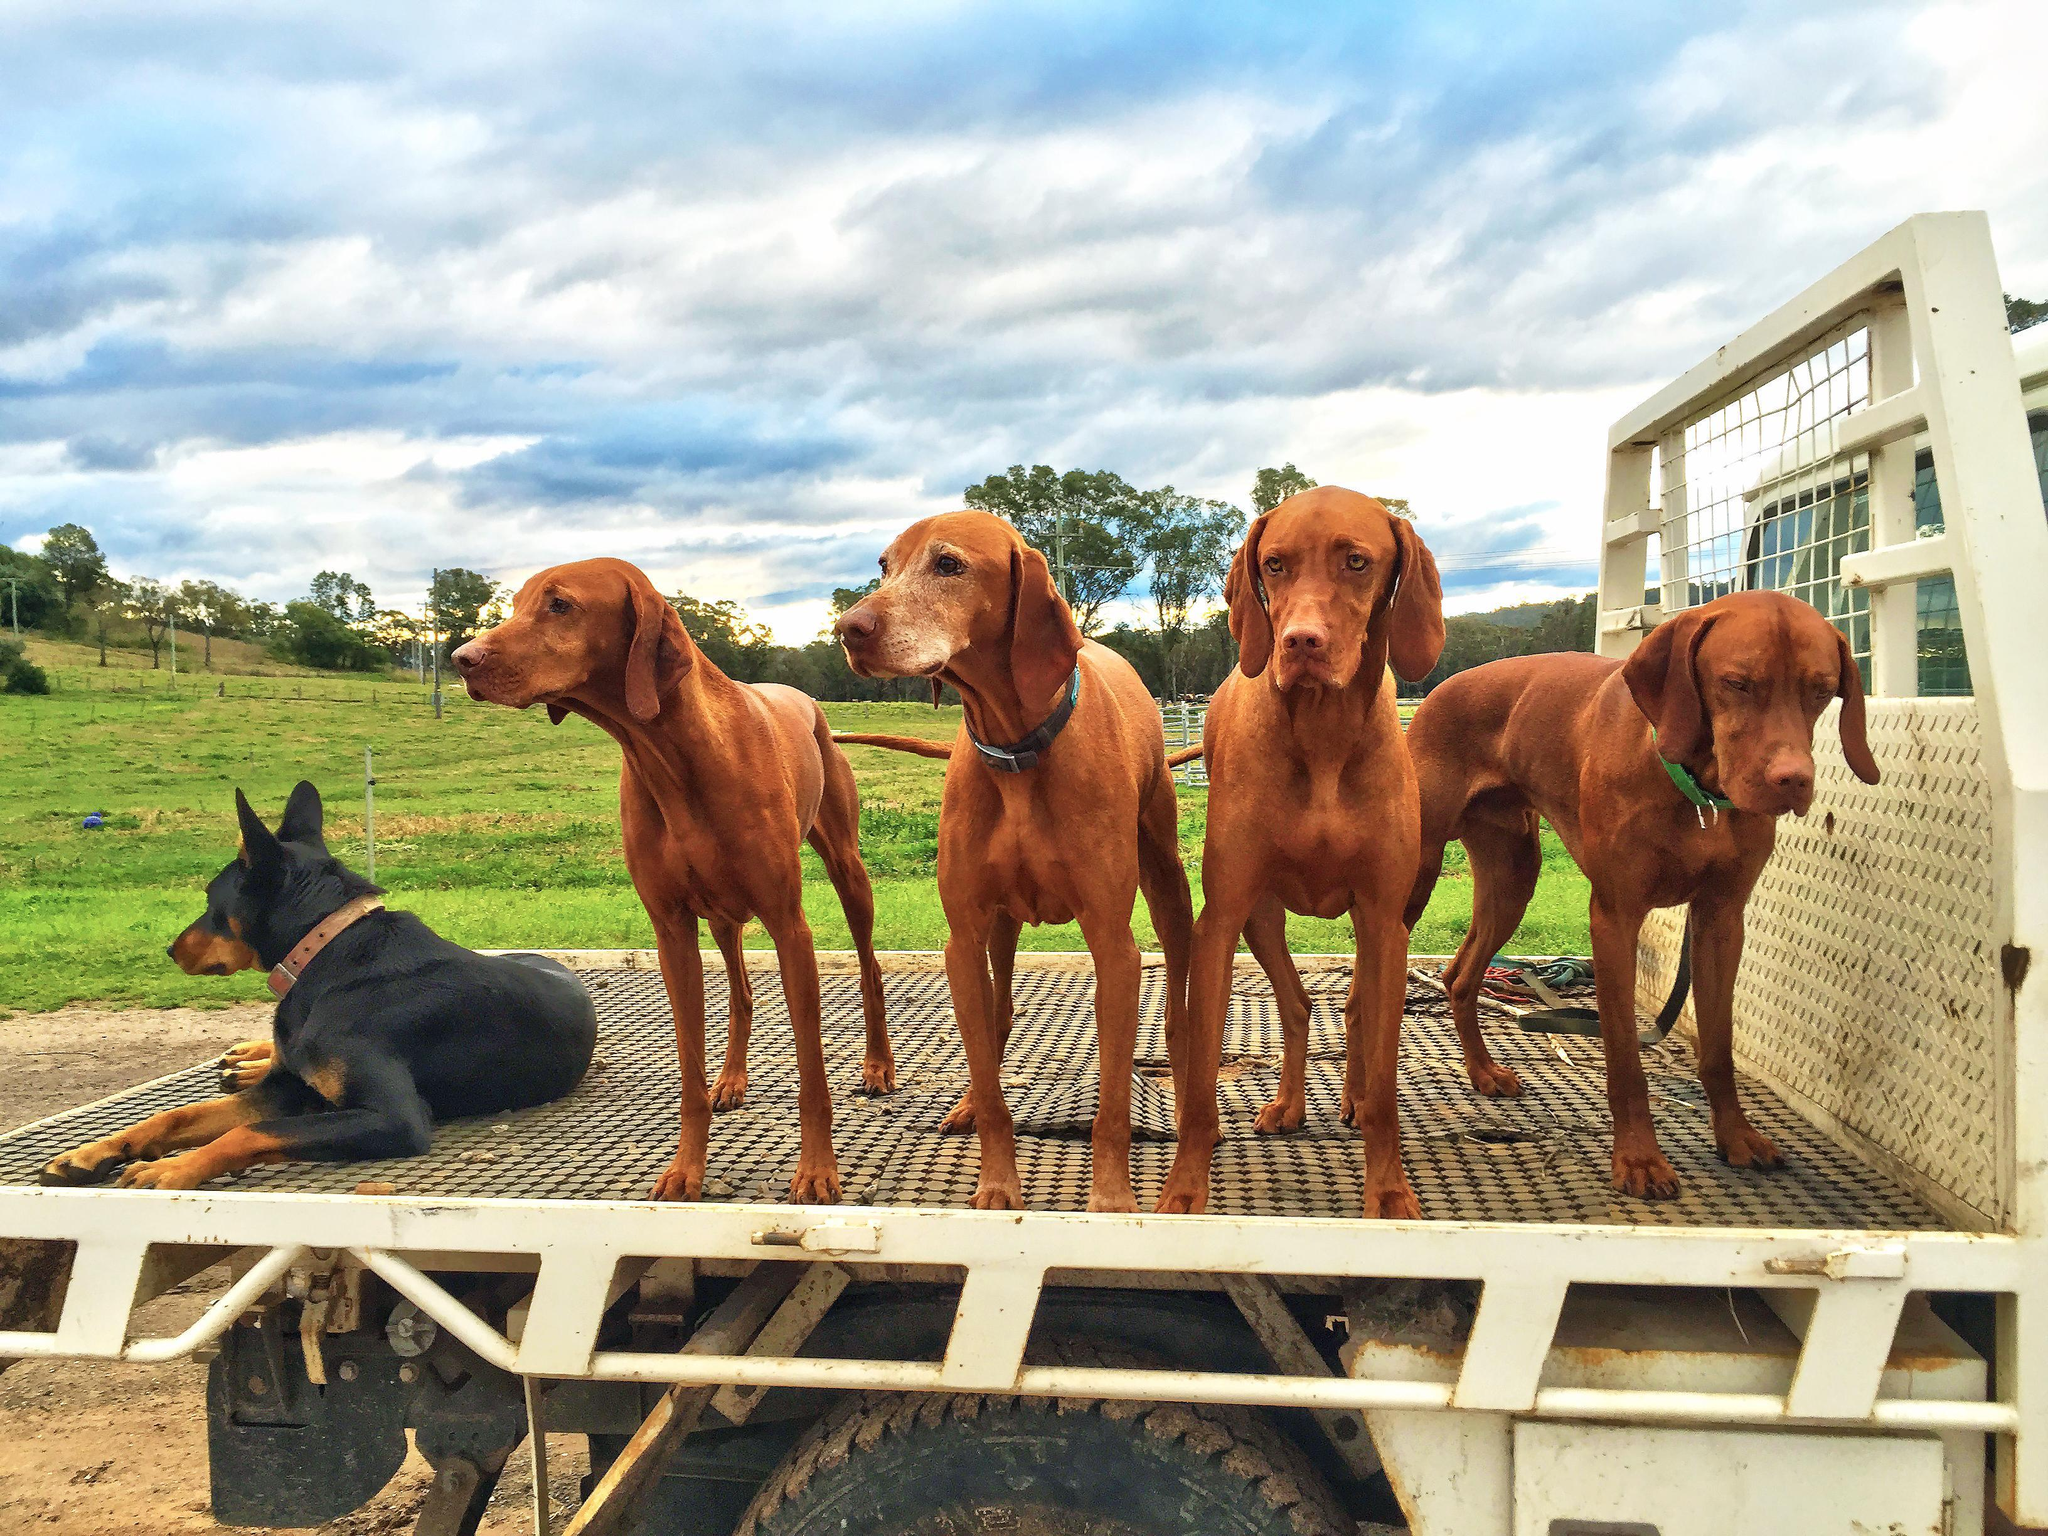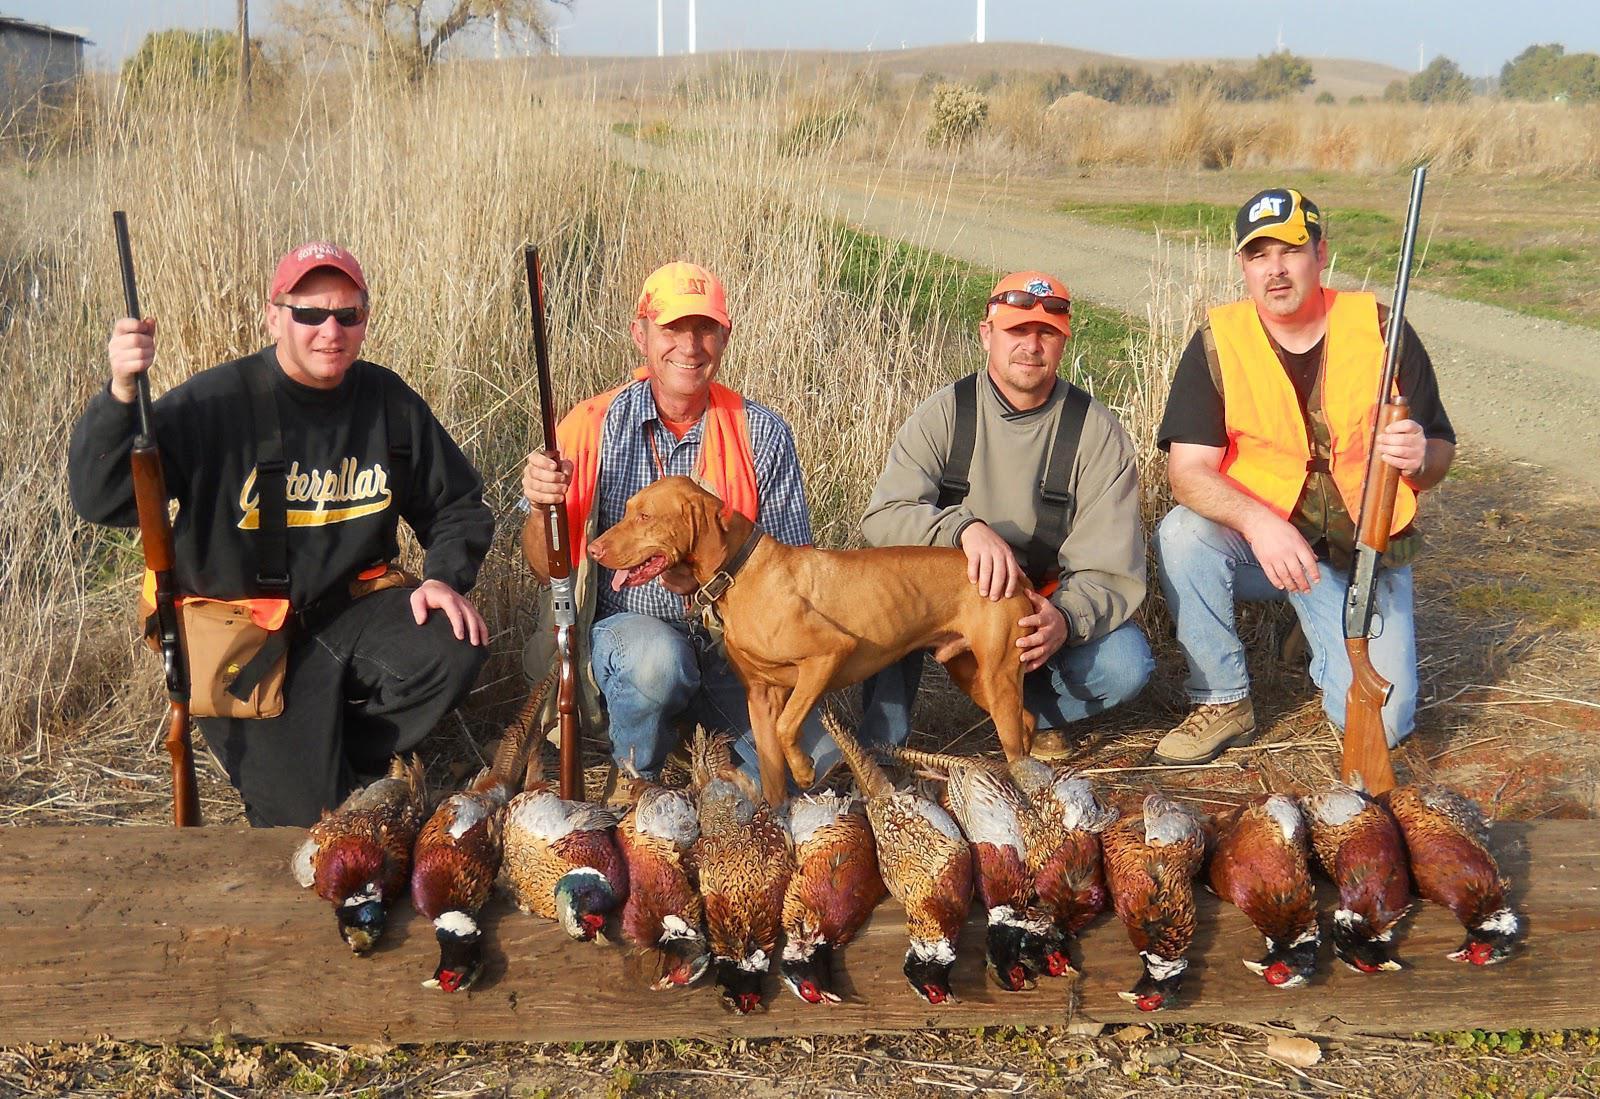The first image is the image on the left, the second image is the image on the right. For the images shown, is this caption "Nine or more mammals are present." true? Answer yes or no. Yes. The first image is the image on the left, the second image is the image on the right. Given the left and right images, does the statement "In one of the images hunters posing with their guns and prey." hold true? Answer yes or no. Yes. 